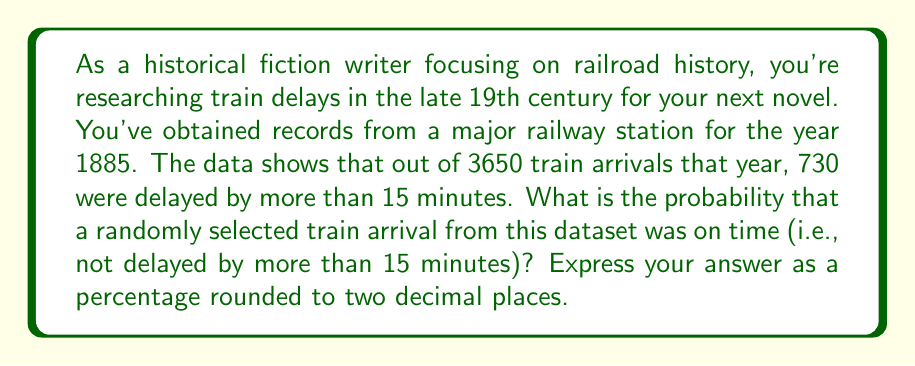Solve this math problem. To solve this problem, we need to follow these steps:

1. Identify the total number of train arrivals:
   $n_{total} = 3650$

2. Identify the number of delayed trains:
   $n_{delayed} = 730$

3. Calculate the number of on-time trains:
   $n_{on-time} = n_{total} - n_{delayed} = 3650 - 730 = 2920$

4. Calculate the probability of an on-time train:
   $$P(on-time) = \frac{n_{on-time}}{n_{total}} = \frac{2920}{3650}$$

5. Convert the probability to a percentage:
   $$P(on-time) \% = \frac{2920}{3650} \times 100\% = 80\%$$

6. Round the result to two decimal places:
   $80.00\%$

Therefore, the probability that a randomly selected train arrival was on time is 80.00%.
Answer: 80.00% 